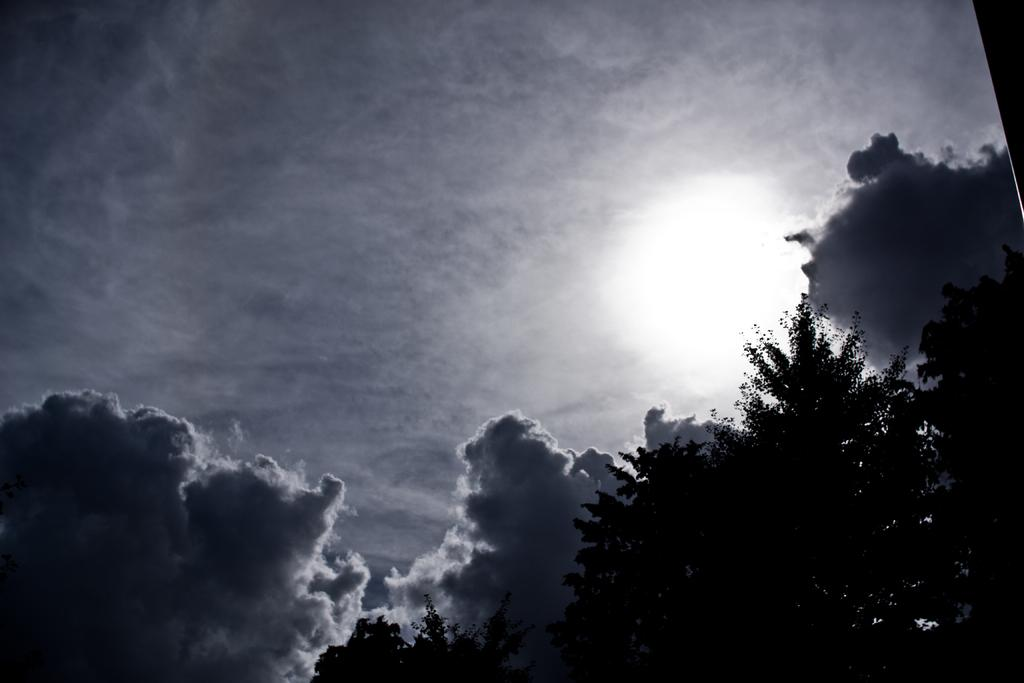What type of vegetation can be seen in the image? There are trees in the image. What part of the natural environment is visible in the image? The sky is visible in the image. What can be observed in the sky in the image? Clouds are present in the image. Where is the faucet located in the image? There is no faucet present in the image. Can you tell me how many volleyballs are visible in the image? There are no volleyballs present in the image. 